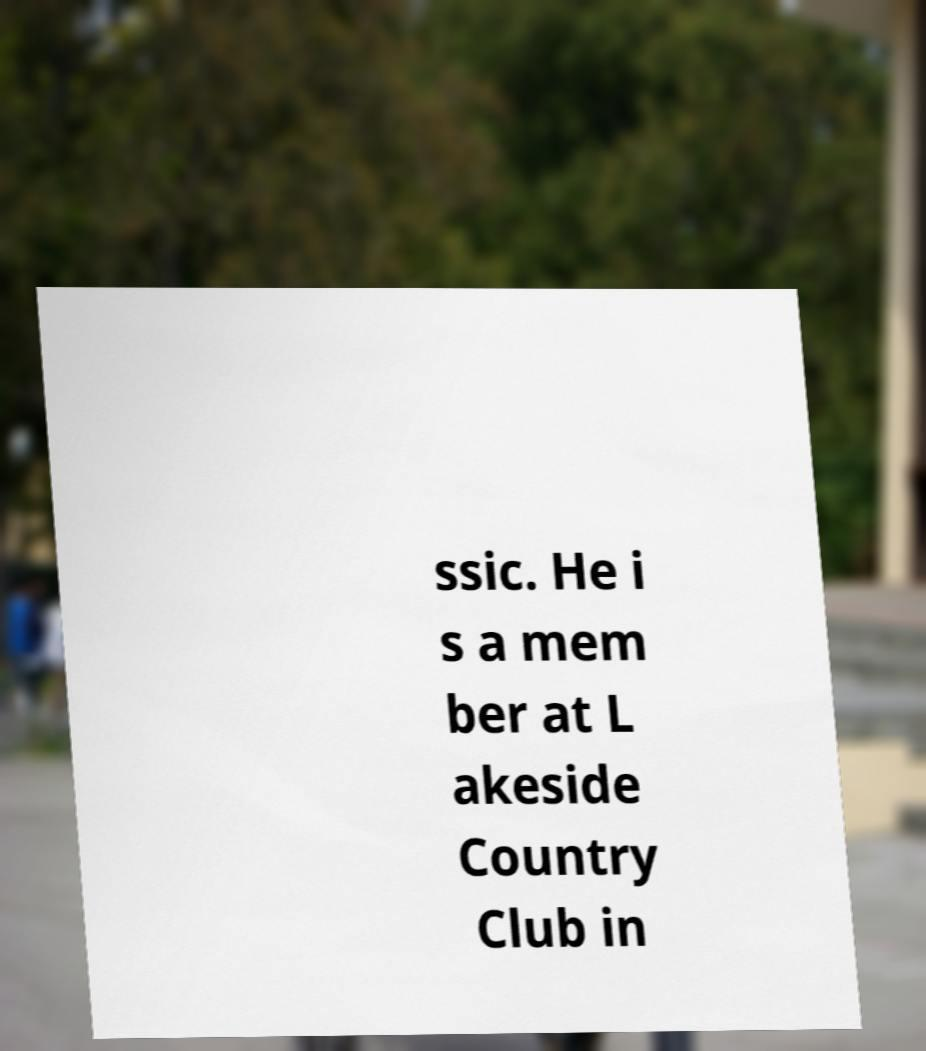Can you accurately transcribe the text from the provided image for me? ssic. He i s a mem ber at L akeside Country Club in 